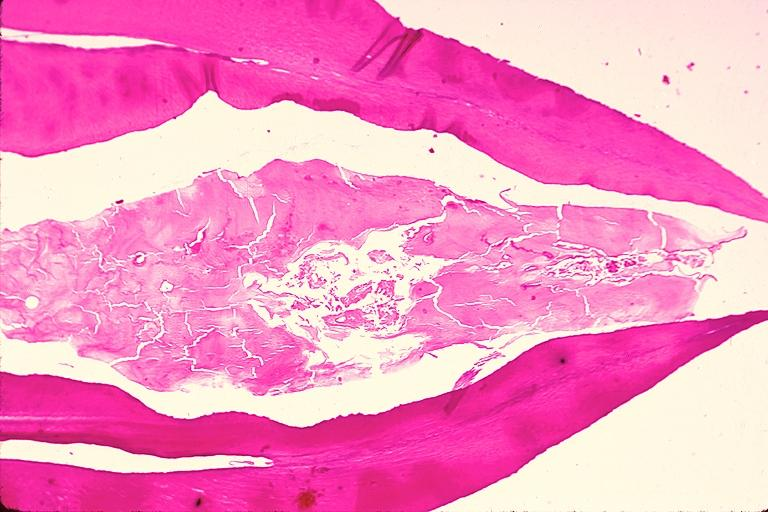does opened muscle show dens invaginatus?
Answer the question using a single word or phrase. No 